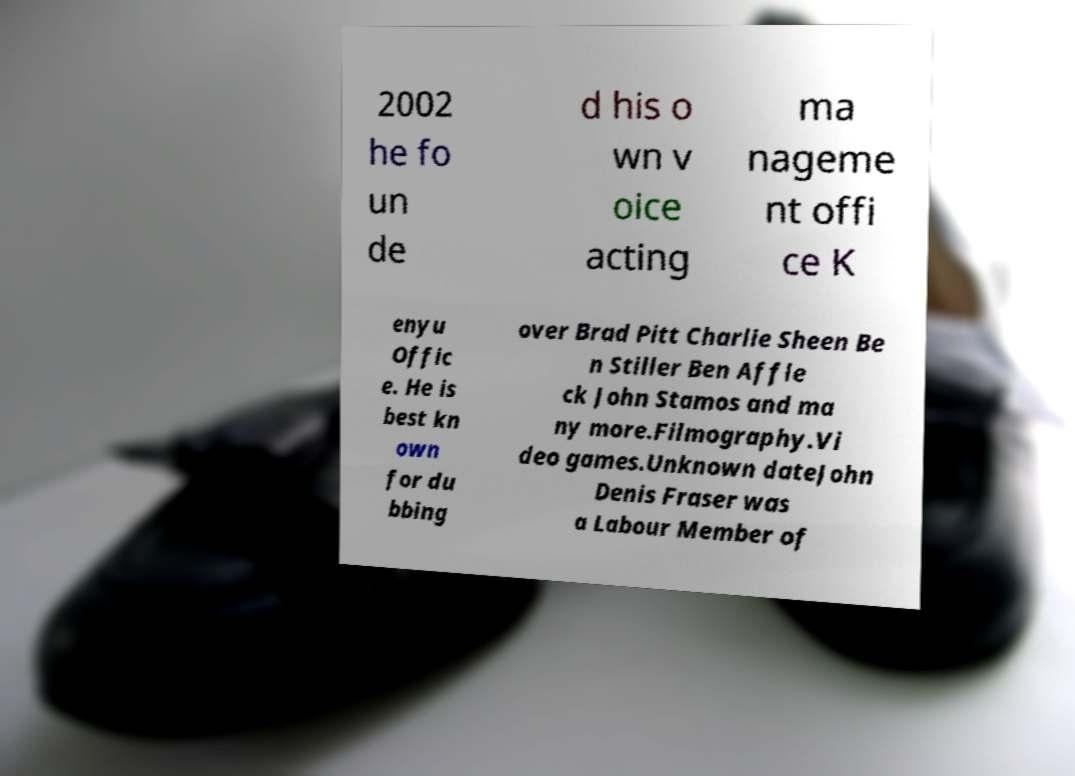Please read and relay the text visible in this image. What does it say? 2002 he fo un de d his o wn v oice acting ma nageme nt offi ce K enyu Offic e. He is best kn own for du bbing over Brad Pitt Charlie Sheen Be n Stiller Ben Affle ck John Stamos and ma ny more.Filmography.Vi deo games.Unknown dateJohn Denis Fraser was a Labour Member of 